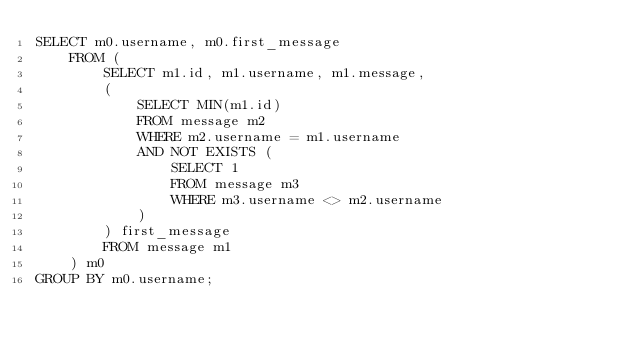Convert code to text. <code><loc_0><loc_0><loc_500><loc_500><_SQL_>SELECT m0.username, m0.first_message
    FROM (
        SELECT m1.id, m1.username, m1.message,
        (
            SELECT MIN(m1.id)
            FROM message m2
            WHERE m2.username = m1.username
            AND NOT EXISTS (
                SELECT 1 
                FROM message m3
                WHERE m3.username <> m2.username
            )
        ) first_message
        FROM message m1
    ) m0 
GROUP BY m0.username;</code> 